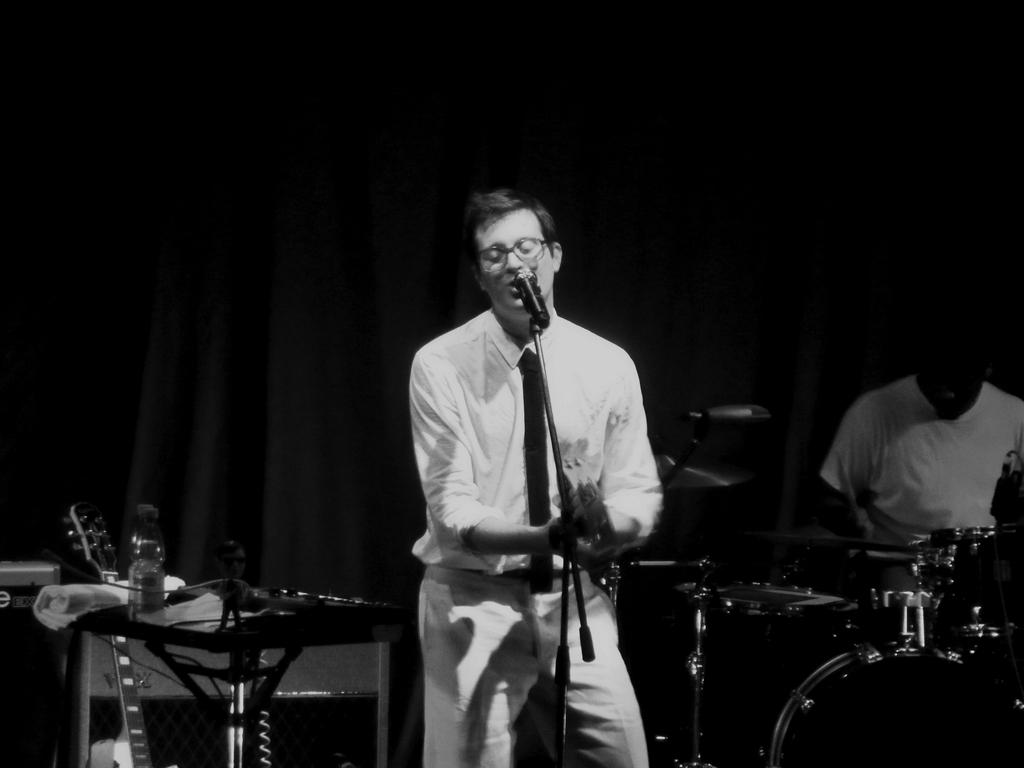What is the man in the image doing with the microphone? The man in the image is singing on a microphone. What instrument is the man also playing in the image? The man is playing a guitar in the image. What is the other man in the image doing? The other man in the image is playing a drum. What type of wine is being served in the image? There is no wine present in the image; it features a man singing on a microphone and playing a guitar, along with another man playing a drum. Can you tell me how many snakes are slithering around the microphone in the image? There are no snakes present in the image; it features a man singing on a microphone and playing a guitar, along with another man playing a drum. 